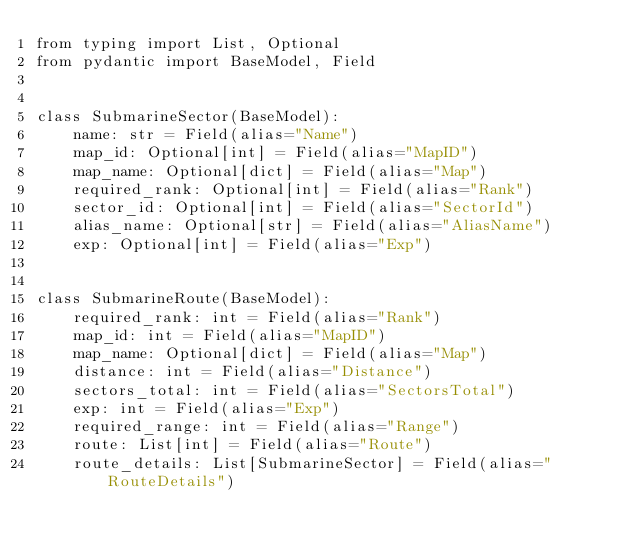Convert code to text. <code><loc_0><loc_0><loc_500><loc_500><_Python_>from typing import List, Optional
from pydantic import BaseModel, Field


class SubmarineSector(BaseModel):
    name: str = Field(alias="Name")
    map_id: Optional[int] = Field(alias="MapID")
    map_name: Optional[dict] = Field(alias="Map")
    required_rank: Optional[int] = Field(alias="Rank")
    sector_id: Optional[int] = Field(alias="SectorId")
    alias_name: Optional[str] = Field(alias="AliasName")
    exp: Optional[int] = Field(alias="Exp")


class SubmarineRoute(BaseModel):
    required_rank: int = Field(alias="Rank")
    map_id: int = Field(alias="MapID")
    map_name: Optional[dict] = Field(alias="Map")
    distance: int = Field(alias="Distance")
    sectors_total: int = Field(alias="SectorsTotal")
    exp: int = Field(alias="Exp")
    required_range: int = Field(alias="Range")
    route: List[int] = Field(alias="Route")
    route_details: List[SubmarineSector] = Field(alias="RouteDetails")
</code> 